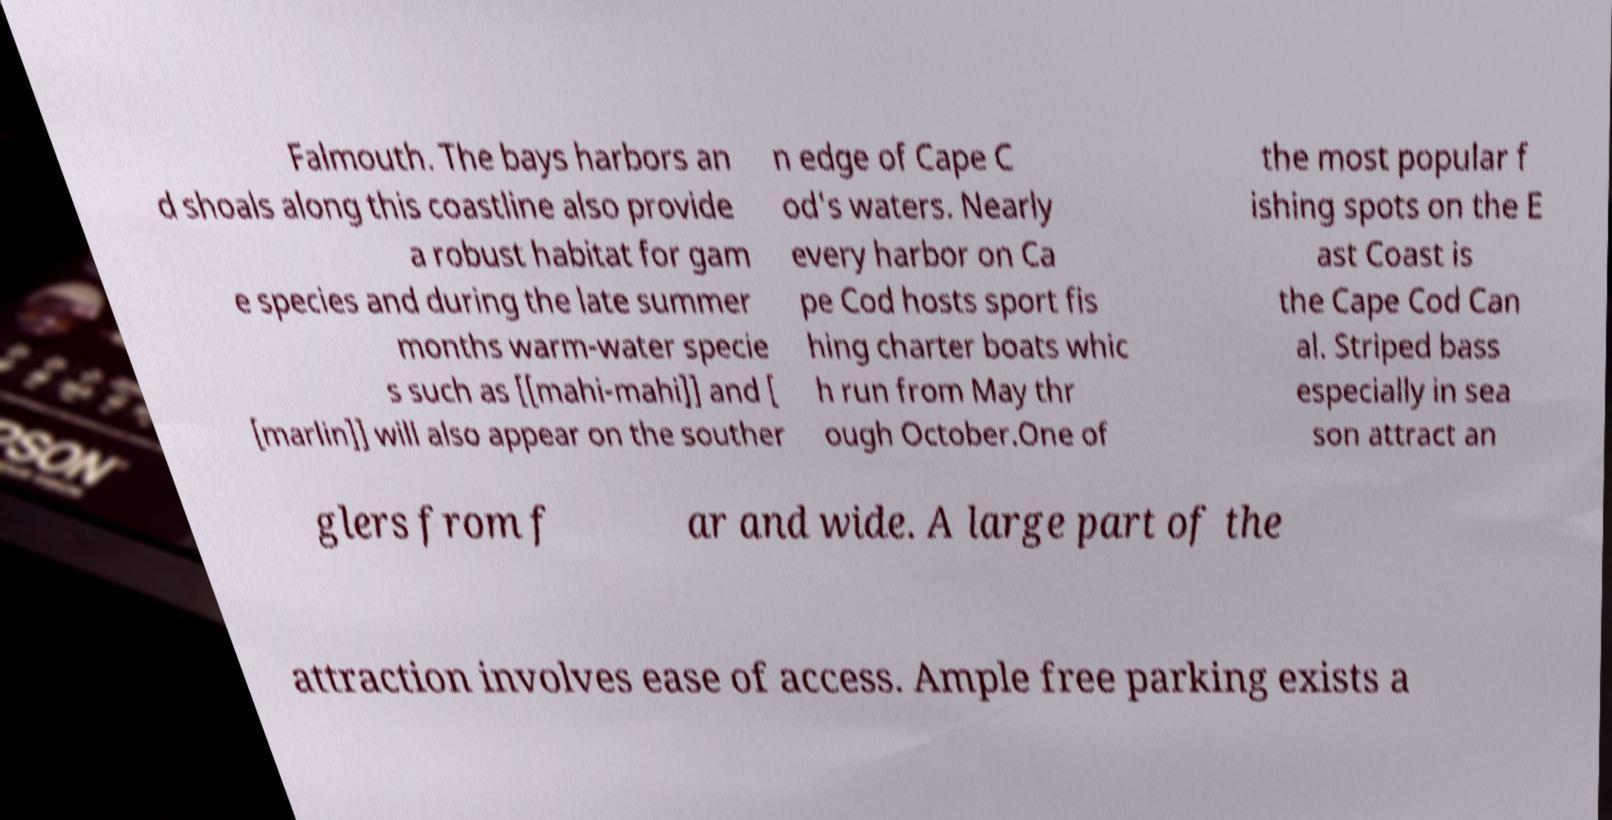Please identify and transcribe the text found in this image. Falmouth. The bays harbors an d shoals along this coastline also provide a robust habitat for gam e species and during the late summer months warm-water specie s such as [[mahi-mahi]] and [ [marlin]] will also appear on the souther n edge of Cape C od's waters. Nearly every harbor on Ca pe Cod hosts sport fis hing charter boats whic h run from May thr ough October.One of the most popular f ishing spots on the E ast Coast is the Cape Cod Can al. Striped bass especially in sea son attract an glers from f ar and wide. A large part of the attraction involves ease of access. Ample free parking exists a 